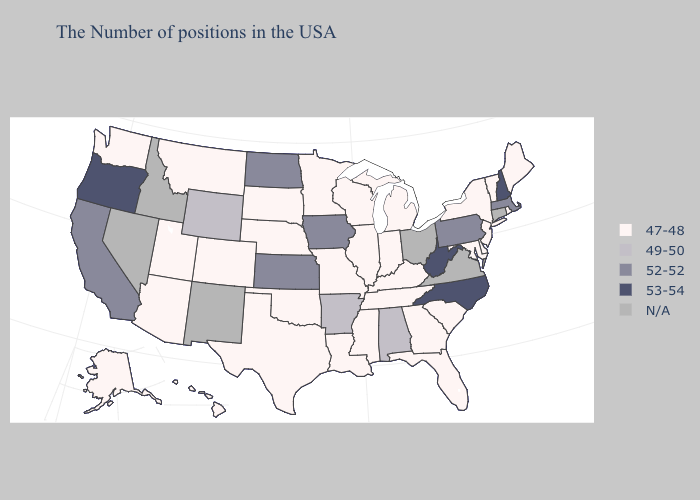Among the states that border Arizona , does Colorado have the highest value?
Concise answer only. No. What is the lowest value in the USA?
Concise answer only. 47-48. Does New Hampshire have the lowest value in the USA?
Keep it brief. No. What is the lowest value in states that border Kansas?
Short answer required. 47-48. What is the value of Nebraska?
Be succinct. 47-48. Does South Dakota have the highest value in the MidWest?
Answer briefly. No. What is the value of Kentucky?
Quick response, please. 47-48. Among the states that border Florida , which have the highest value?
Be succinct. Alabama. What is the highest value in states that border Nebraska?
Answer briefly. 52-52. How many symbols are there in the legend?
Keep it brief. 5. What is the value of Indiana?
Write a very short answer. 47-48. What is the highest value in the USA?
Concise answer only. 53-54. What is the value of Massachusetts?
Keep it brief. 52-52. Name the states that have a value in the range 52-52?
Quick response, please. Massachusetts, Pennsylvania, Iowa, Kansas, North Dakota, California. Does Vermont have the lowest value in the Northeast?
Keep it brief. Yes. 